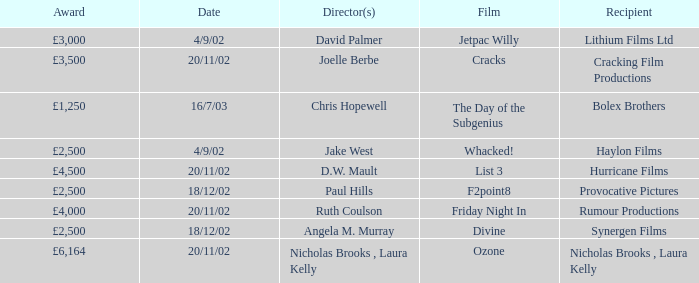Parse the full table. {'header': ['Award', 'Date', 'Director(s)', 'Film', 'Recipient'], 'rows': [['£3,000', '4/9/02', 'David Palmer', 'Jetpac Willy', 'Lithium Films Ltd'], ['£3,500', '20/11/02', 'Joelle Berbe', 'Cracks', 'Cracking Film Productions'], ['£1,250', '16/7/03', 'Chris Hopewell', 'The Day of the Subgenius', 'Bolex Brothers'], ['£2,500', '4/9/02', 'Jake West', 'Whacked!', 'Haylon Films'], ['£4,500', '20/11/02', 'D.W. Mault', 'List 3', 'Hurricane Films'], ['£2,500', '18/12/02', 'Paul Hills', 'F2point8', 'Provocative Pictures'], ['£4,000', '20/11/02', 'Ruth Coulson', 'Friday Night In', 'Rumour Productions'], ['£2,500', '18/12/02', 'Angela M. Murray', 'Divine', 'Synergen Films'], ['£6,164', '20/11/02', 'Nicholas Brooks , Laura Kelly', 'Ozone', 'Nicholas Brooks , Laura Kelly']]} What prize was awarded to the ozone film? £6,164. 